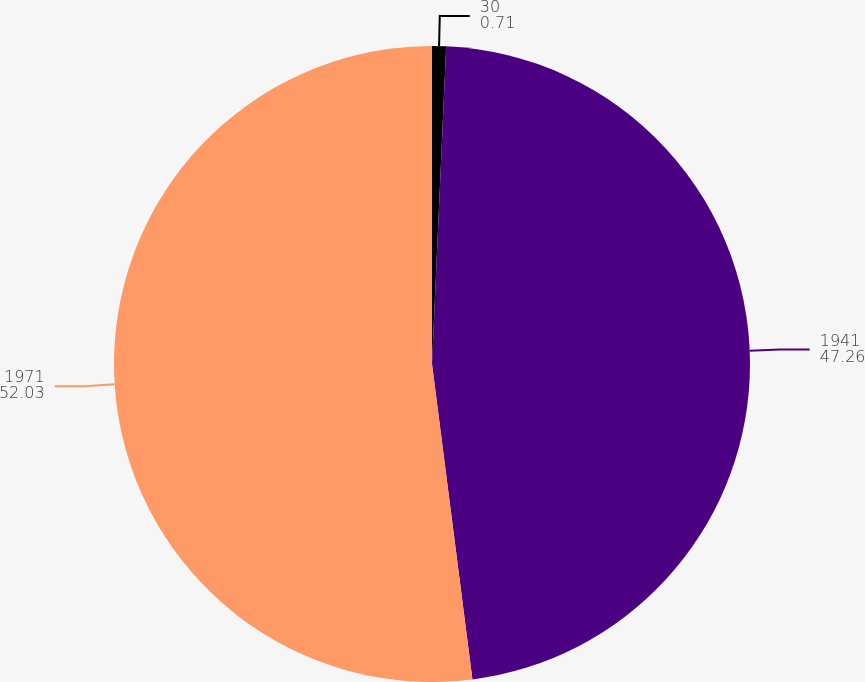Convert chart to OTSL. <chart><loc_0><loc_0><loc_500><loc_500><pie_chart><fcel>30<fcel>1941<fcel>1971<nl><fcel>0.71%<fcel>47.26%<fcel>52.03%<nl></chart> 